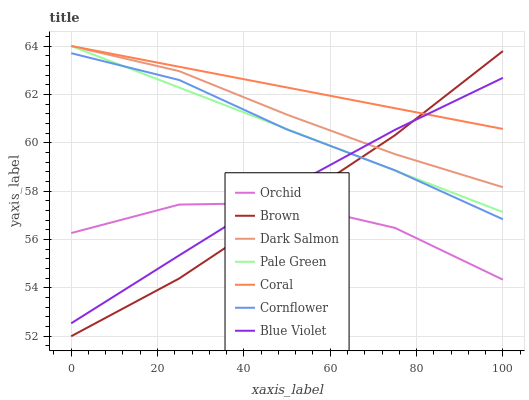Does Orchid have the minimum area under the curve?
Answer yes or no. Yes. Does Coral have the maximum area under the curve?
Answer yes or no. Yes. Does Brown have the minimum area under the curve?
Answer yes or no. No. Does Brown have the maximum area under the curve?
Answer yes or no. No. Is Coral the smoothest?
Answer yes or no. Yes. Is Orchid the roughest?
Answer yes or no. Yes. Is Brown the smoothest?
Answer yes or no. No. Is Brown the roughest?
Answer yes or no. No. Does Coral have the lowest value?
Answer yes or no. No. Does Pale Green have the highest value?
Answer yes or no. Yes. Does Brown have the highest value?
Answer yes or no. No. Is Orchid less than Dark Salmon?
Answer yes or no. Yes. Is Pale Green greater than Orchid?
Answer yes or no. Yes. Does Pale Green intersect Brown?
Answer yes or no. Yes. Is Pale Green less than Brown?
Answer yes or no. No. Is Pale Green greater than Brown?
Answer yes or no. No. Does Orchid intersect Dark Salmon?
Answer yes or no. No. 